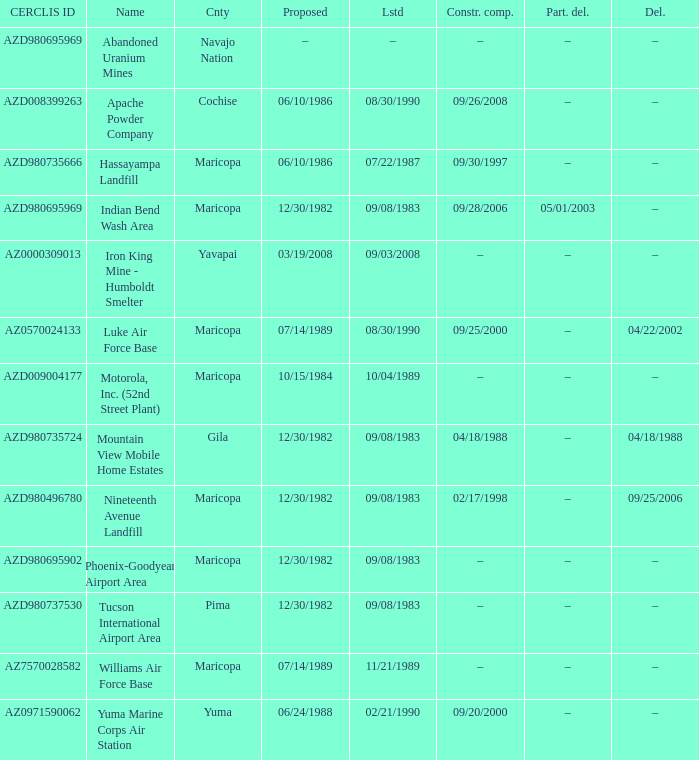When was the site listed when the county is cochise? 08/30/1990. 